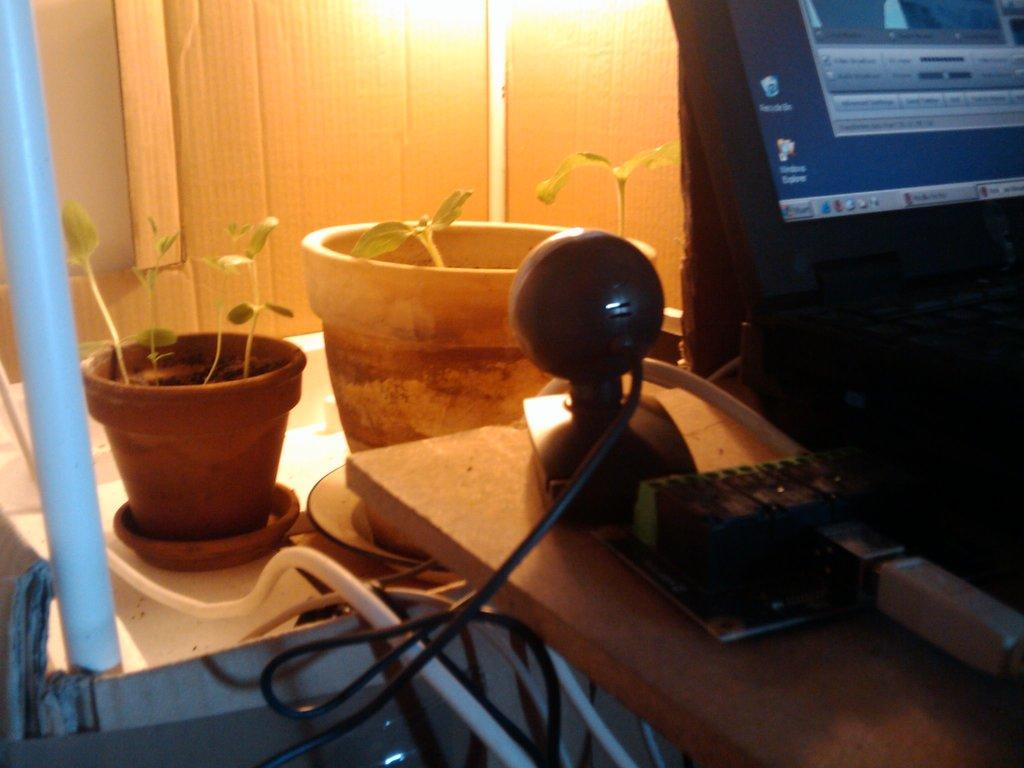What electronic device is present in the image? There is a monitor in the image. What is placed on the surface of the monitor? There are objects on the surface of the monitor. What type of greenery can be seen in the image? There are house plants in the image. What connects the monitor to other devices or power sources? There are cables visible in the image. What can be seen in the background of the image? There is a wall and lights in the background of the image. What is the plot of the story being told by the things on the monitor? There is no story being told by the things on the monitor, as they are likely objects and not characters in a narrative. What type of string is used to hold the lights in the background of the image? There is no string visible in the image; the lights are likely attached to the wall or ceiling. 